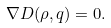<formula> <loc_0><loc_0><loc_500><loc_500>\nabla D ( \rho , { q } ) = 0 .</formula> 